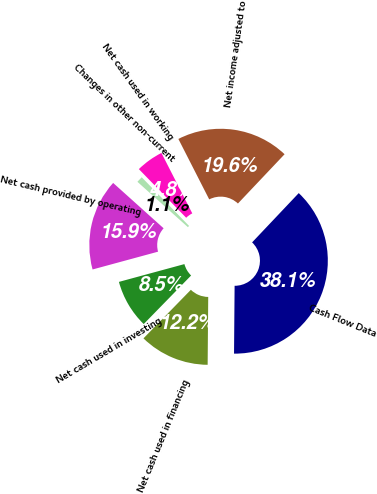Convert chart. <chart><loc_0><loc_0><loc_500><loc_500><pie_chart><fcel>Cash Flow Data<fcel>Net income adjusted to<fcel>Net cash used in working<fcel>Changes in other non-current<fcel>Net cash provided by operating<fcel>Net cash used in investing<fcel>Net cash used in financing<nl><fcel>38.07%<fcel>19.57%<fcel>4.77%<fcel>1.07%<fcel>15.87%<fcel>8.47%<fcel>12.17%<nl></chart> 